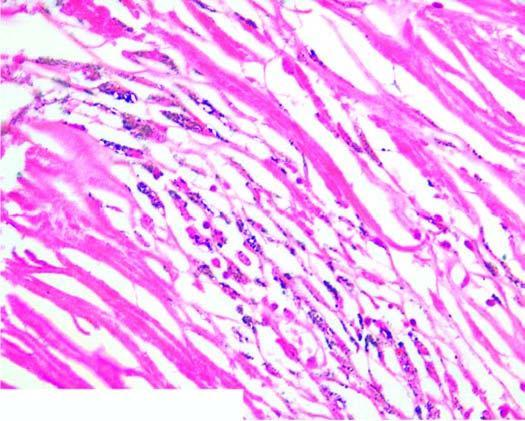what consists of hyaline centre surrounded by concentric layers of collagen which are further enclosed by fibroblasts and dust-laden macrophages?
Answer the question using a single word or phrase. Silicotic nodule 